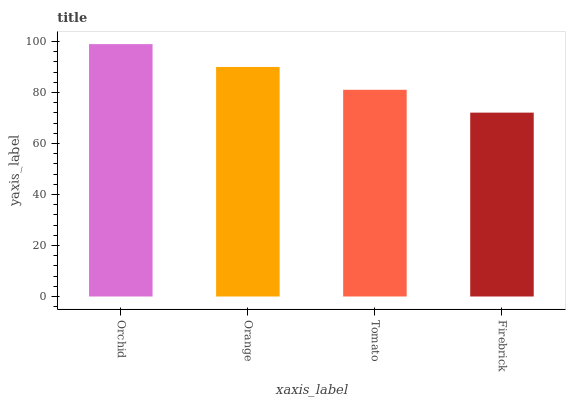Is Firebrick the minimum?
Answer yes or no. Yes. Is Orchid the maximum?
Answer yes or no. Yes. Is Orange the minimum?
Answer yes or no. No. Is Orange the maximum?
Answer yes or no. No. Is Orchid greater than Orange?
Answer yes or no. Yes. Is Orange less than Orchid?
Answer yes or no. Yes. Is Orange greater than Orchid?
Answer yes or no. No. Is Orchid less than Orange?
Answer yes or no. No. Is Orange the high median?
Answer yes or no. Yes. Is Tomato the low median?
Answer yes or no. Yes. Is Orchid the high median?
Answer yes or no. No. Is Firebrick the low median?
Answer yes or no. No. 